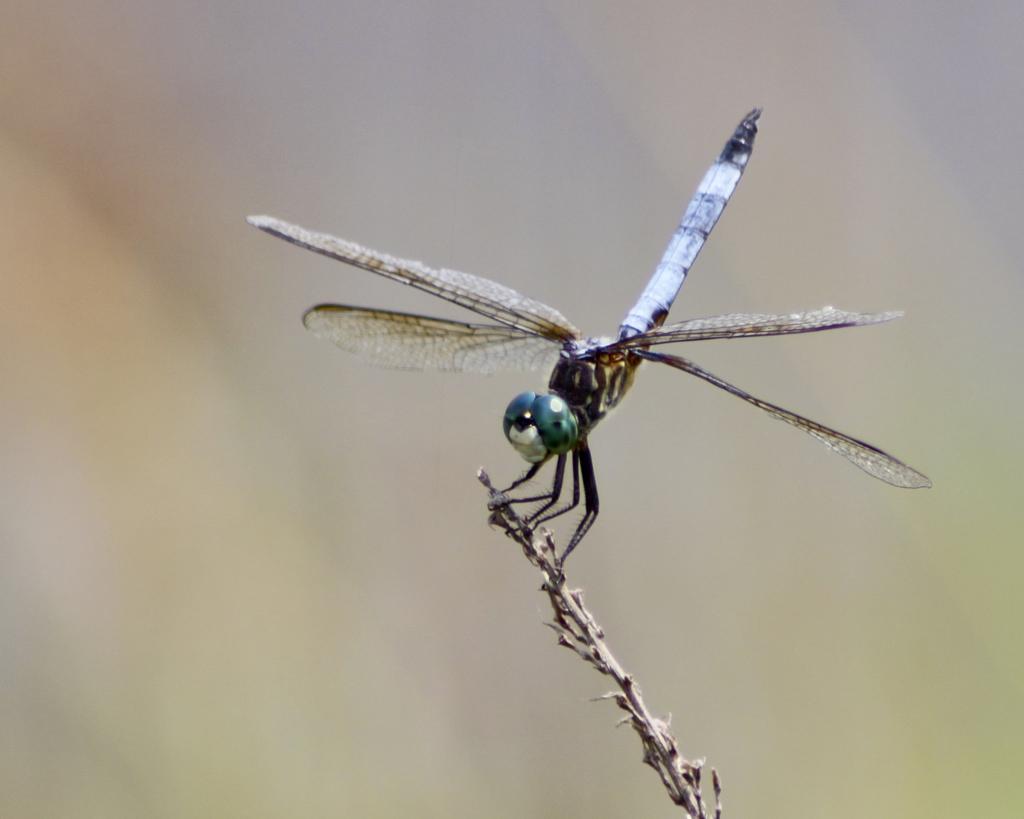How would you summarize this image in a sentence or two? In this picture there is a dragonfly on the plant. At the back the image is blurry. 